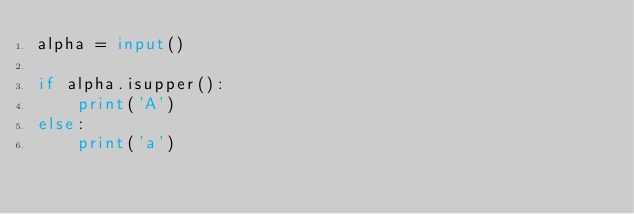<code> <loc_0><loc_0><loc_500><loc_500><_Python_>alpha = input()

if alpha.isupper():
    print('A')
else:
    print('a')</code> 